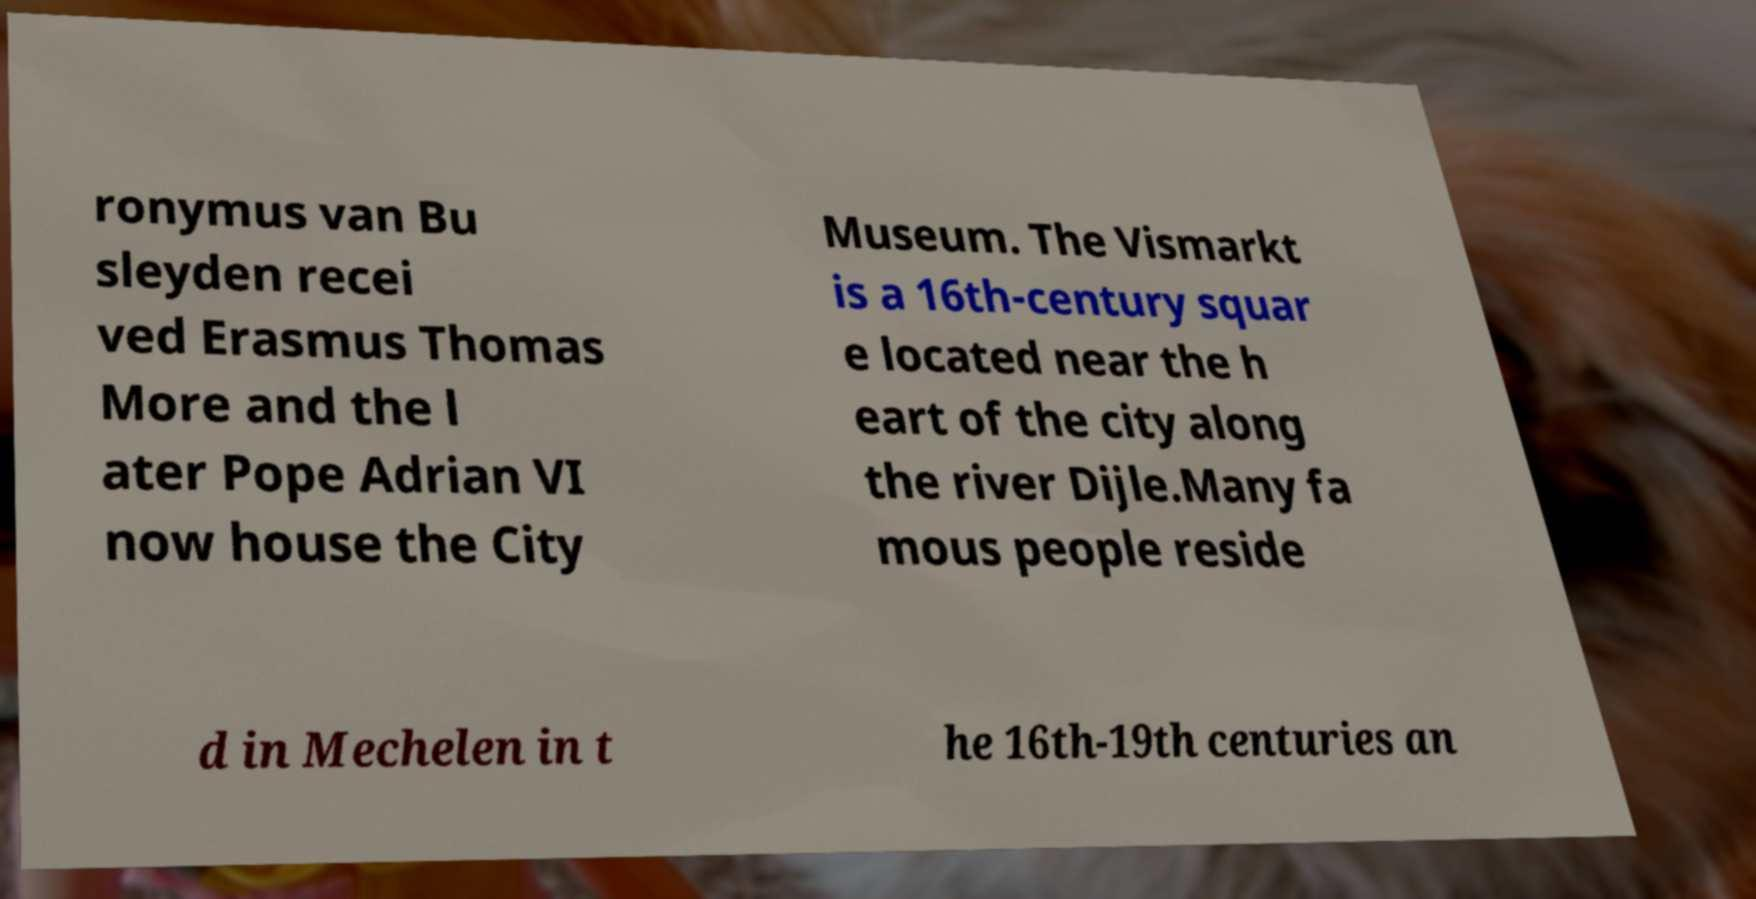What messages or text are displayed in this image? I need them in a readable, typed format. ronymus van Bu sleyden recei ved Erasmus Thomas More and the l ater Pope Adrian VI now house the City Museum. The Vismarkt is a 16th-century squar e located near the h eart of the city along the river Dijle.Many fa mous people reside d in Mechelen in t he 16th-19th centuries an 